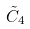Convert formula to latex. <formula><loc_0><loc_0><loc_500><loc_500>\tilde { C } _ { 4 }</formula> 